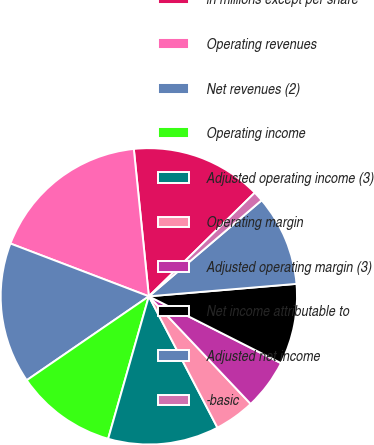Convert chart. <chart><loc_0><loc_0><loc_500><loc_500><pie_chart><fcel>in millions except per share<fcel>Operating revenues<fcel>Net revenues (2)<fcel>Operating income<fcel>Adjusted operating income (3)<fcel>Operating margin<fcel>Adjusted operating margin (3)<fcel>Net income attributable to<fcel>Adjusted net income<fcel>-basic<nl><fcel>14.29%<fcel>17.58%<fcel>15.38%<fcel>10.99%<fcel>12.09%<fcel>4.4%<fcel>5.49%<fcel>8.79%<fcel>9.89%<fcel>1.1%<nl></chart> 